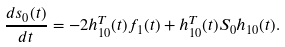<formula> <loc_0><loc_0><loc_500><loc_500>\frac { d s _ { 0 } ( t ) } { d t } = - 2 h _ { 1 0 } ^ { T } ( t ) f _ { 1 } ( t ) + h _ { 1 0 } ^ { T } ( t ) S _ { 0 } h _ { 1 0 } ( t ) .</formula> 